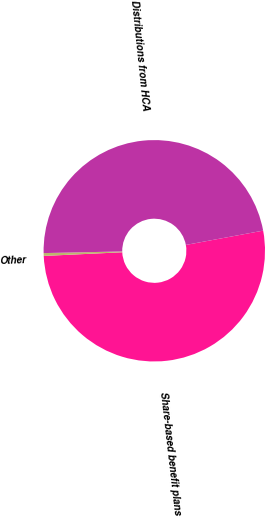Convert chart. <chart><loc_0><loc_0><loc_500><loc_500><pie_chart><fcel>Share-based benefit plans<fcel>Other<fcel>Distributions from HCA<nl><fcel>52.17%<fcel>0.41%<fcel>47.42%<nl></chart> 